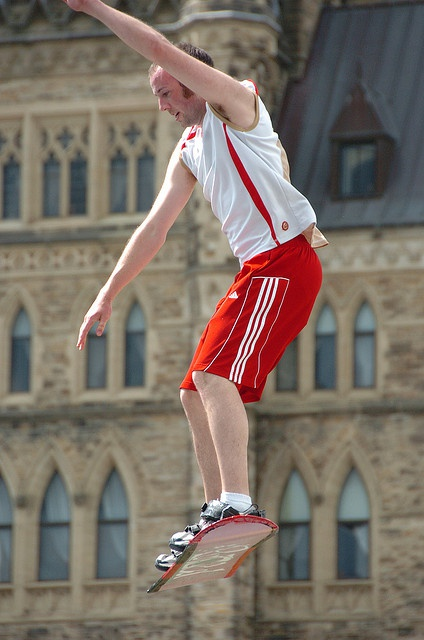Describe the objects in this image and their specific colors. I can see people in blue, darkgray, brown, lightgray, and gray tones and snowboard in blue, darkgray, gray, and brown tones in this image. 